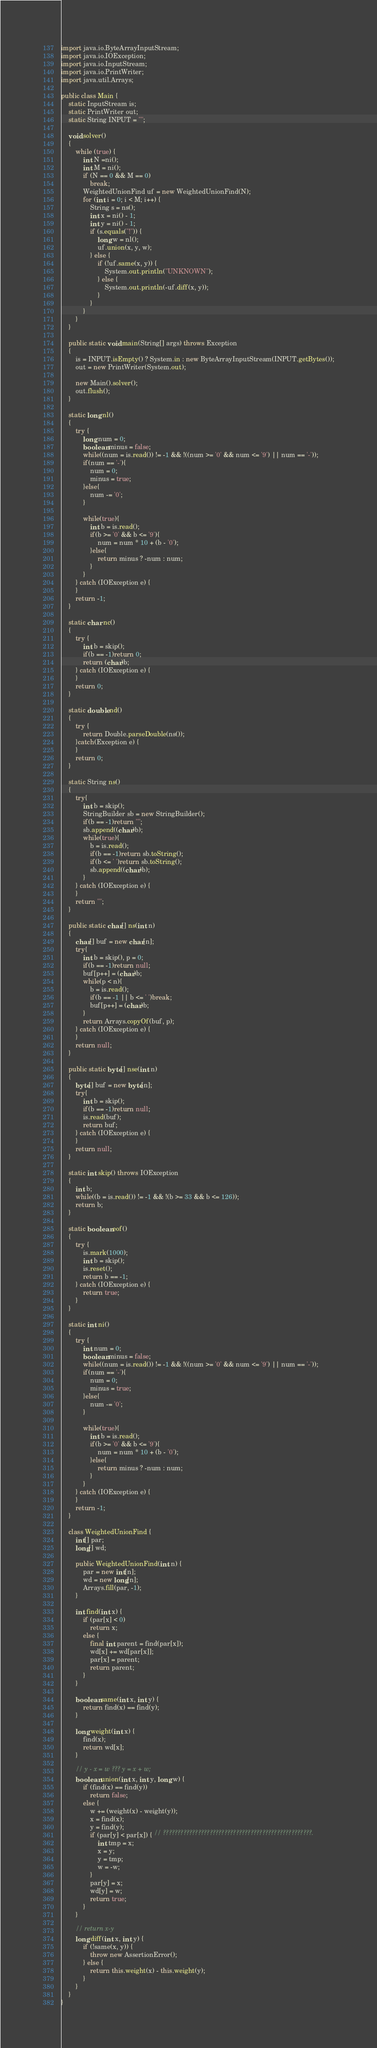<code> <loc_0><loc_0><loc_500><loc_500><_Java_>import java.io.ByteArrayInputStream;
import java.io.IOException;
import java.io.InputStream;
import java.io.PrintWriter;
import java.util.Arrays;

public class Main {
	static InputStream is;
	static PrintWriter out;
	static String INPUT = "";

	void solver()
	{
		while (true) {
			int N =ni();
			int M = ni();
			if (N == 0 && M == 0)
				break;
			WeightedUnionFind uf = new WeightedUnionFind(N);
			for (int i = 0; i < M; i++) {
				String s = ns();
				int x = ni() - 1;
				int y = ni() - 1;
				if (s.equals("!")) {
					long w = nl();
					uf.union(x, y, w);
				} else {
					if (!uf.same(x, y)) {
						System.out.println("UNKNOWN");
					} else {
						System.out.println(-uf.diff(x, y));
					}
				}
			}
		}
	}

	public static void main(String[] args) throws Exception
	{
		is = INPUT.isEmpty() ? System.in : new ByteArrayInputStream(INPUT.getBytes());
		out = new PrintWriter(System.out);

		new Main().solver();
		out.flush();
	}

	static long nl()
	{
		try {
			long num = 0;
			boolean minus = false;
			while((num = is.read()) != -1 && !((num >= '0' && num <= '9') || num == '-'));
			if(num == '-'){
				num = 0;
				minus = true;
			}else{
				num -= '0';
			}

			while(true){
				int b = is.read();
				if(b >= '0' && b <= '9'){
					num = num * 10 + (b - '0');
				}else{
					return minus ? -num : num;
				}
			}
		} catch (IOException e) {
		}
		return -1;
	}

	static char nc()
	{
		try {
			int b = skip();
			if(b == -1)return 0;
			return (char)b;
		} catch (IOException e) {
		}
		return 0;
	}

	static double nd()
	{
		try {
			return Double.parseDouble(ns());
		}catch(Exception e) {
		}
		return 0;
	}

	static String ns()
	{
		try{
			int b = skip();
			StringBuilder sb = new StringBuilder();
			if(b == -1)return "";
			sb.append((char)b);
			while(true){
				b = is.read();
				if(b == -1)return sb.toString();
				if(b <= ' ')return sb.toString();
				sb.append((char)b);
			}
		} catch (IOException e) {
		}
		return "";
	}

	public static char[] ns(int n)
	{
		char[] buf = new char[n];
		try{
			int b = skip(), p = 0;
			if(b == -1)return null;
			buf[p++] = (char)b;
			while(p < n){
				b = is.read();
				if(b == -1 || b <= ' ')break;
				buf[p++] = (char)b;
			}
			return Arrays.copyOf(buf, p);
		} catch (IOException e) {
		}
		return null;
	}

	public static byte[] nse(int n)
	{
		byte[] buf = new byte[n];
		try{
			int b = skip();
			if(b == -1)return null;
			is.read(buf);
			return buf;
		} catch (IOException e) {
		}
		return null;
	}

	static int skip() throws IOException
	{
		int b;
		while((b = is.read()) != -1 && !(b >= 33 && b <= 126));
		return b;
	}

	static boolean eof()
	{
		try {
			is.mark(1000);
			int b = skip();
			is.reset();
			return b == -1;
		} catch (IOException e) {
			return true;
		}
	}

	static int ni()
	{
		try {
			int num = 0;
			boolean minus = false;
			while((num = is.read()) != -1 && !((num >= '0' && num <= '9') || num == '-'));
			if(num == '-'){
				num = 0;
				minus = true;
			}else{
				num -= '0';
			}

			while(true){
				int b = is.read();
				if(b >= '0' && b <= '9'){
					num = num * 10 + (b - '0');
				}else{
					return minus ? -num : num;
				}
			}
		} catch (IOException e) {
		}
		return -1;
	}

	class WeightedUnionFind {
		int[] par;
		long[] wd;

		public WeightedUnionFind(int n) {
			par = new int[n];
			wd = new long[n];
			Arrays.fill(par, -1);
		}

		int find(int x) {
			if (par[x] < 0)
				return x;
			else {
				final int parent = find(par[x]);
				wd[x] += wd[par[x]];
				par[x] = parent;
				return parent;
			}
		}

		boolean same(int x, int y) {
			return find(x) == find(y);
		}

		long weight(int x) {
			find(x);
			return wd[x];
		}

		// y - x = w ??? y = x + w;
		boolean union(int x, int y, long w) {
			if (find(x) == find(y))
				return false;
			else {
				w += (weight(x) - weight(y));
				x = find(x);
				y = find(y);
				if (par[y] < par[x]) { // ???????????????????????????????????????????????????.
					int tmp = x;
					x = y;
					y = tmp;
					w = -w;
				}
				par[y] = x;
				wd[y] = w;
				return true;
			}
		}

		// return x-y
		long diff(int x, int y) {
			if (!same(x, y)) {
				throw new AssertionError();
			} else {
				return this.weight(x) - this.weight(y);
			}
		}
	}
}</code> 